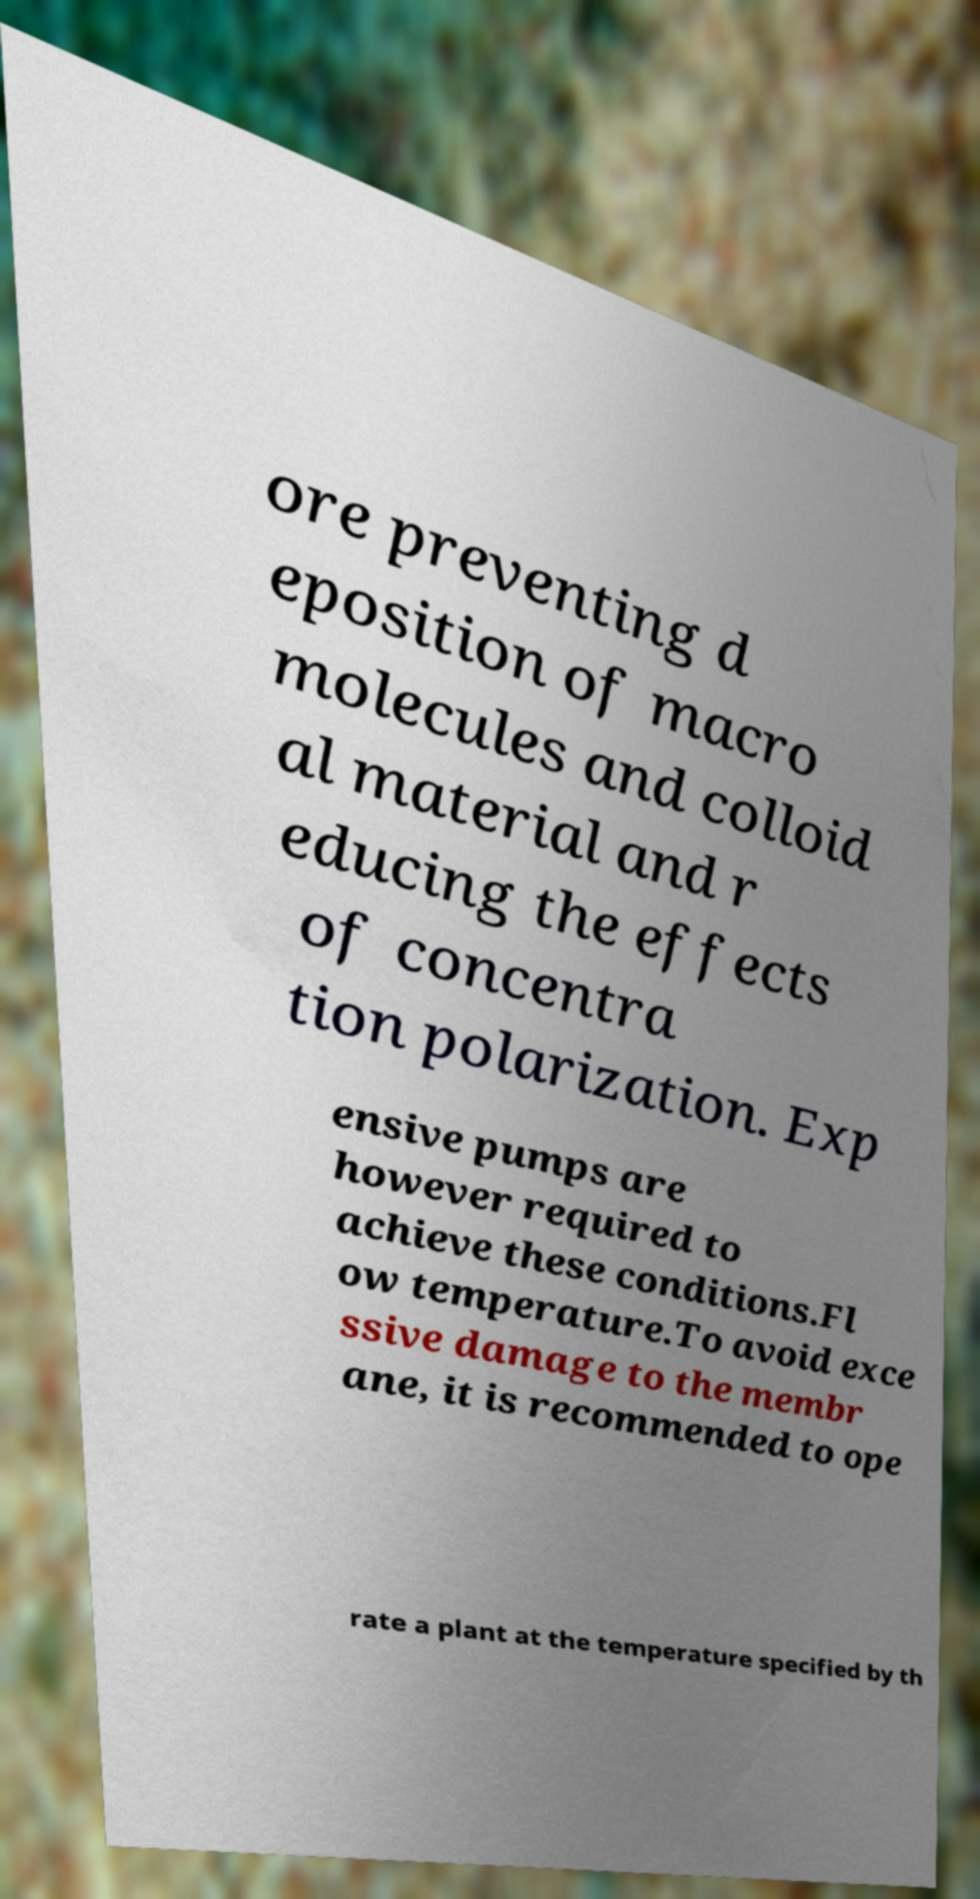What messages or text are displayed in this image? I need them in a readable, typed format. ore preventing d eposition of macro molecules and colloid al material and r educing the effects of concentra tion polarization. Exp ensive pumps are however required to achieve these conditions.Fl ow temperature.To avoid exce ssive damage to the membr ane, it is recommended to ope rate a plant at the temperature specified by th 